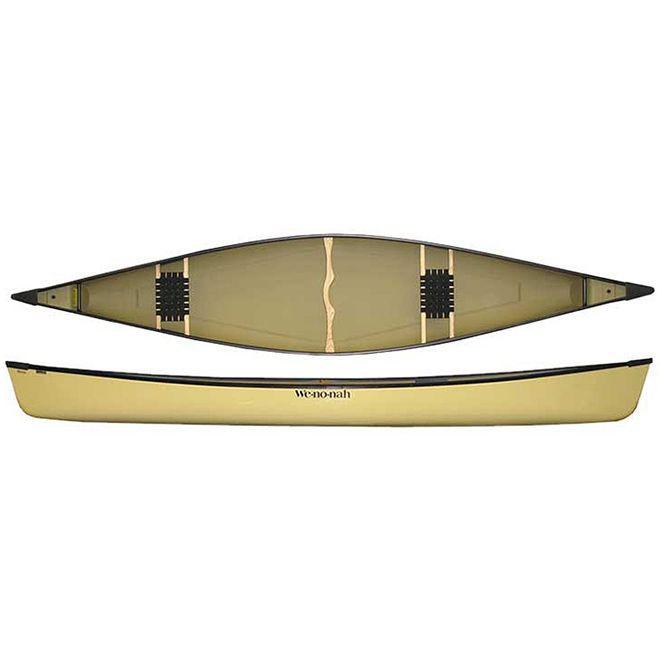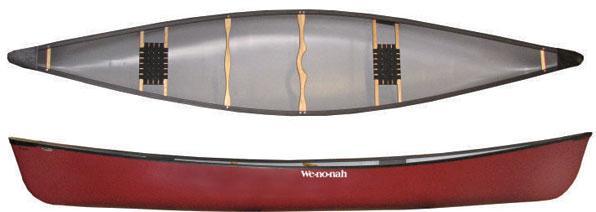The first image is the image on the left, the second image is the image on the right. Examine the images to the left and right. Is the description "Each image features a top-viewed canoe above a side view of a canoe." accurate? Answer yes or no. Yes. The first image is the image on the left, the second image is the image on the right. Examine the images to the left and right. Is the description "There is a yellow canoe." accurate? Answer yes or no. Yes. 